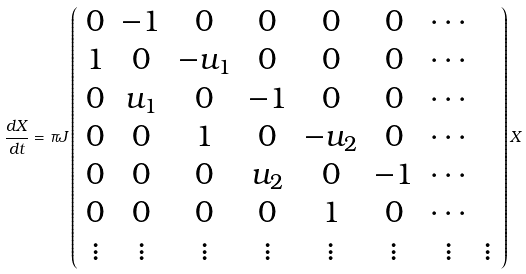<formula> <loc_0><loc_0><loc_500><loc_500>\frac { d X } { d t } = \pi J \left ( \begin{array} { c c c c c c c c } 0 & - 1 & 0 & 0 & 0 & 0 & \cdots \\ 1 & 0 & - u _ { 1 } & 0 & 0 & 0 & \cdots \\ 0 & u _ { 1 } & 0 & - 1 & 0 & 0 & \cdots \\ 0 & 0 & 1 & 0 & - u _ { 2 } & 0 & \cdots \\ 0 & 0 & 0 & u _ { 2 } & 0 & - 1 & \cdots \\ 0 & 0 & 0 & 0 & 1 & 0 & \cdots \\ \vdots & \vdots & \vdots & \vdots & \vdots & \vdots & \vdots & \vdots \end{array} \right ) X</formula> 